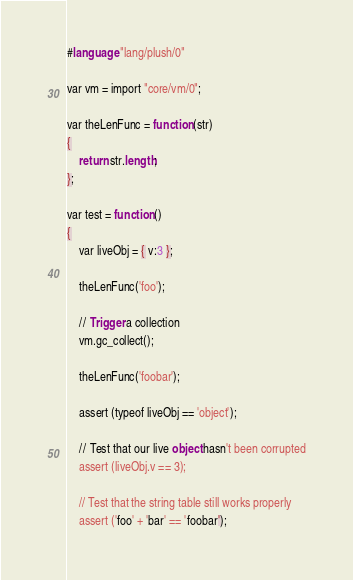Convert code to text. <code><loc_0><loc_0><loc_500><loc_500><_SQL_>#language "lang/plush/0"

var vm = import "core/vm/0";

var theLenFunc = function (str)
{
    return str.length;
};

var test = function ()
{
    var liveObj = { v:3 };

    theLenFunc('foo');

    // Trigger a collection
    vm.gc_collect();

    theLenFunc('foobar');

    assert (typeof liveObj == 'object');

    // Test that our live object hasn't been corrupted
    assert (liveObj.v == 3);

    // Test that the string table still works properly
    assert ('foo' + 'bar' == 'foobar');
</code> 